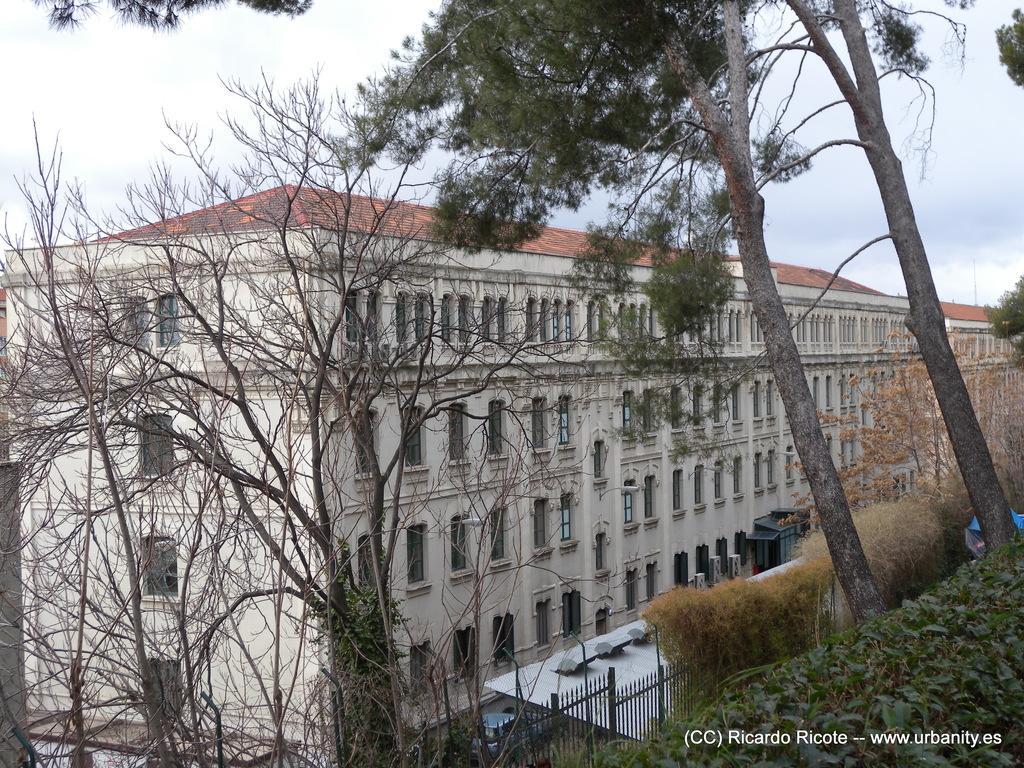In one or two sentences, can you explain what this image depicts? In the picture I can see trees, buildings, fence, plants and some other objects. In the background I can see the sky. On the button right corner of the image I can see a watermark. 